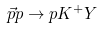Convert formula to latex. <formula><loc_0><loc_0><loc_500><loc_500>\vec { p } p \rightarrow p K ^ { + } Y</formula> 